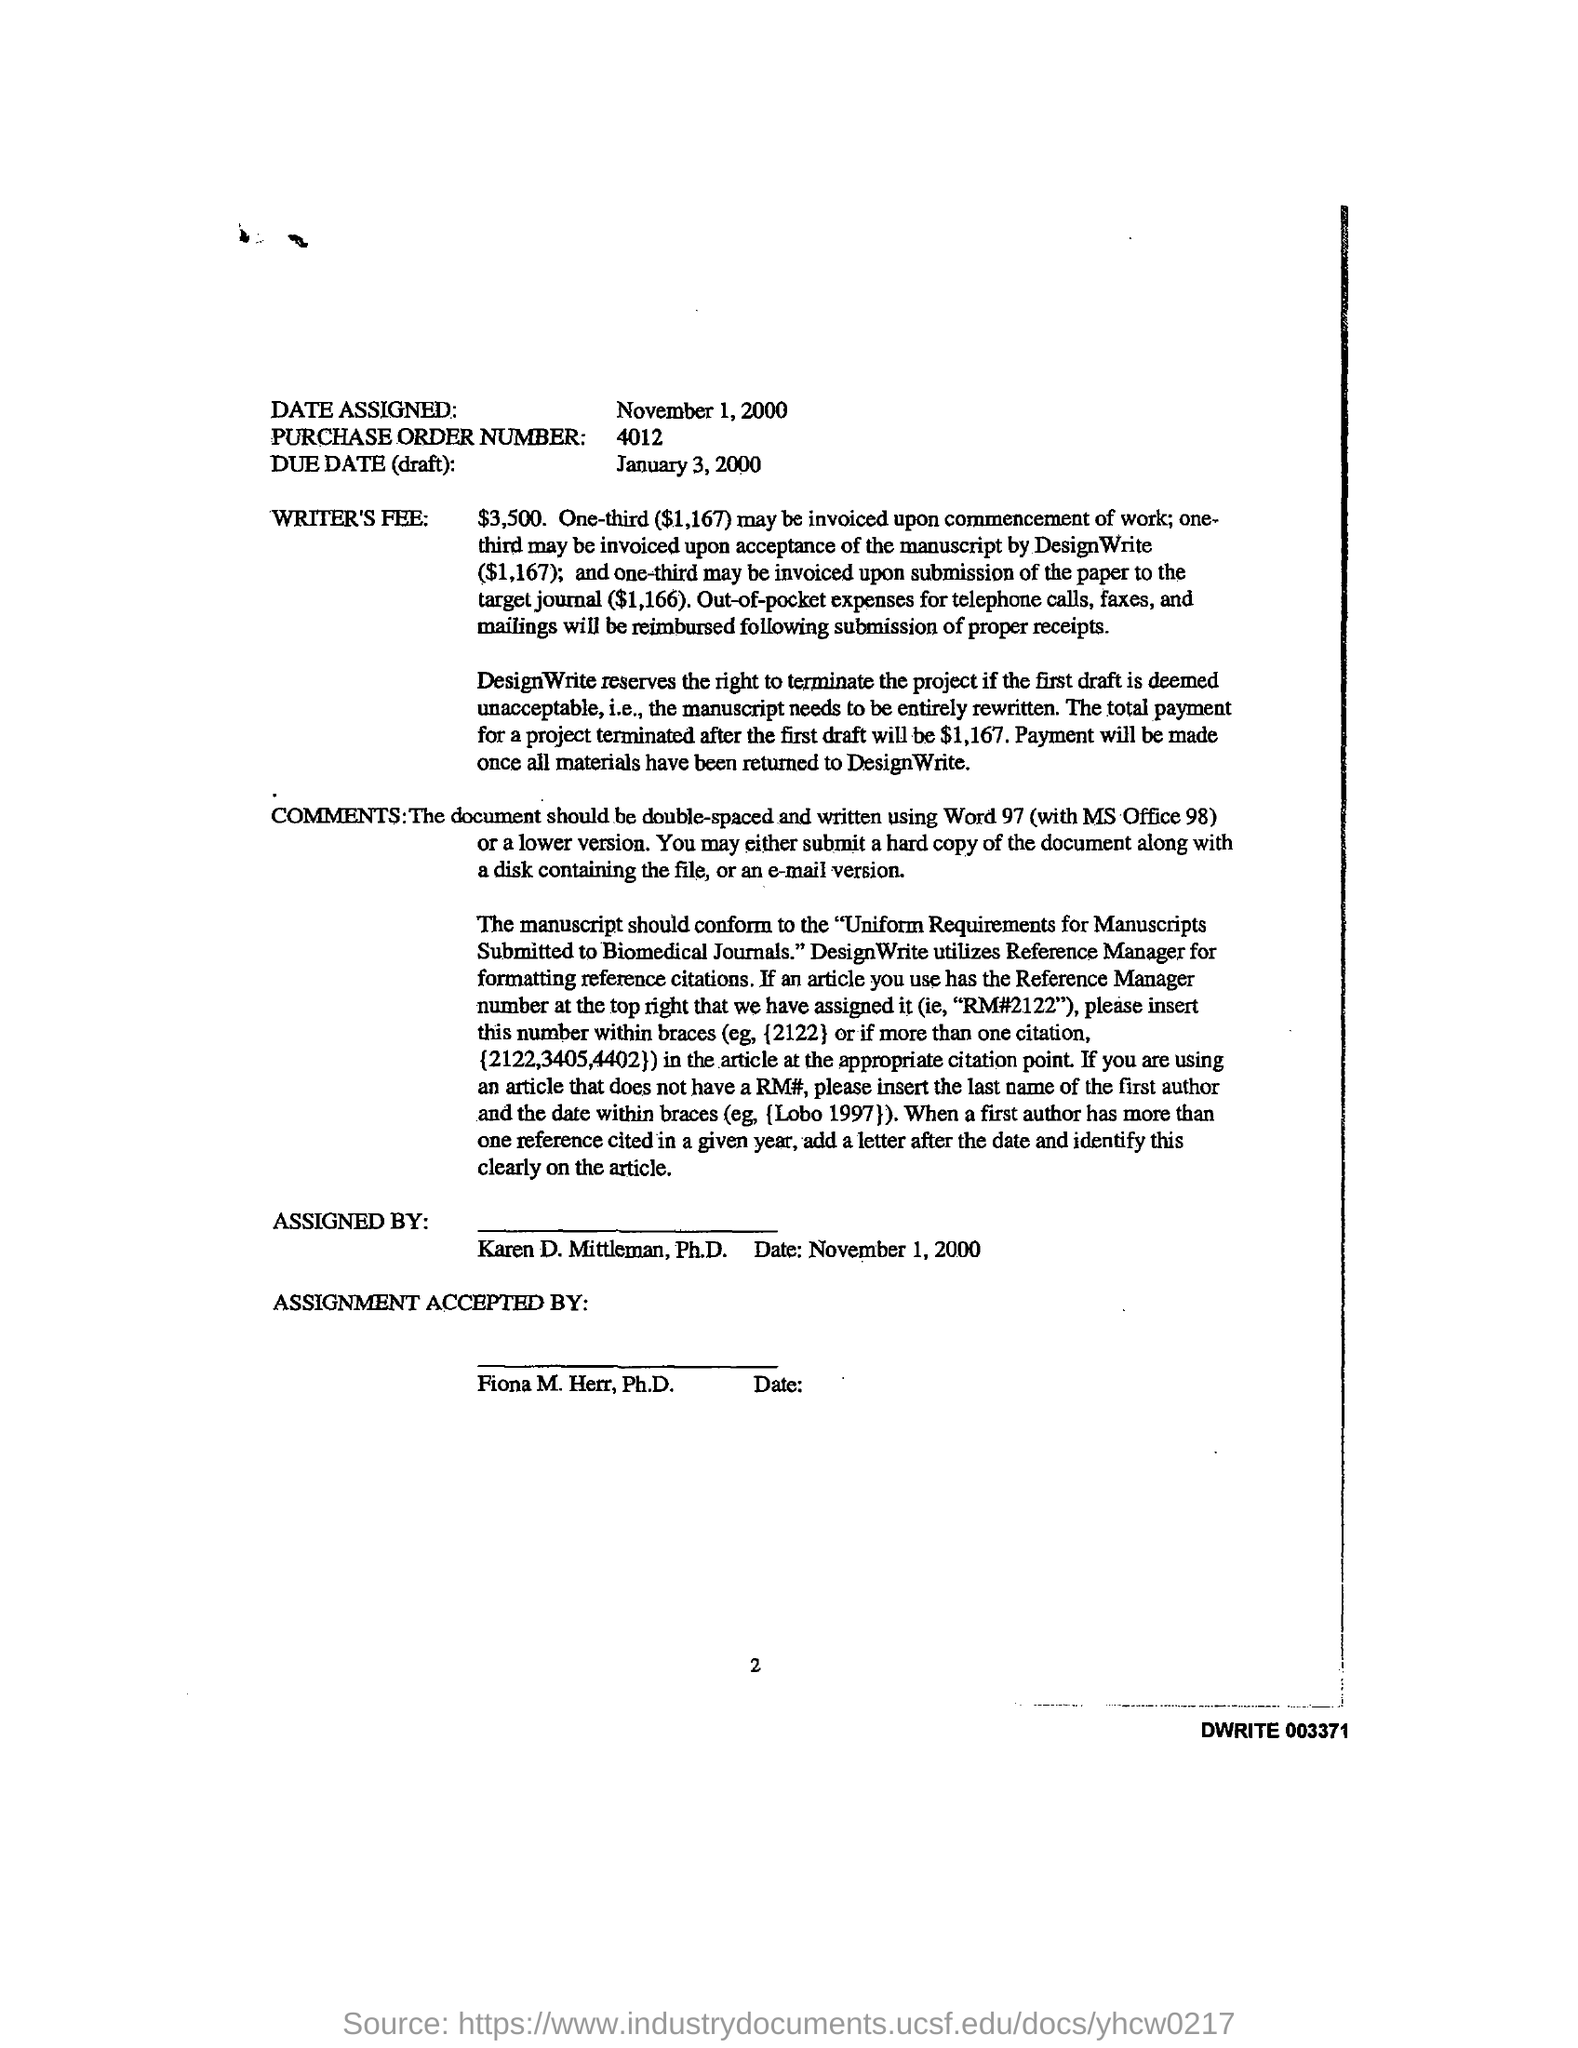Identify some key points in this picture. A purchase order number is a unique identifier assigned to a specific purchase order. The number may consist of digits, such as "4012. The rights to terminate the project are reserved by DesignWrite. The assigned date is November 1, 2000. 